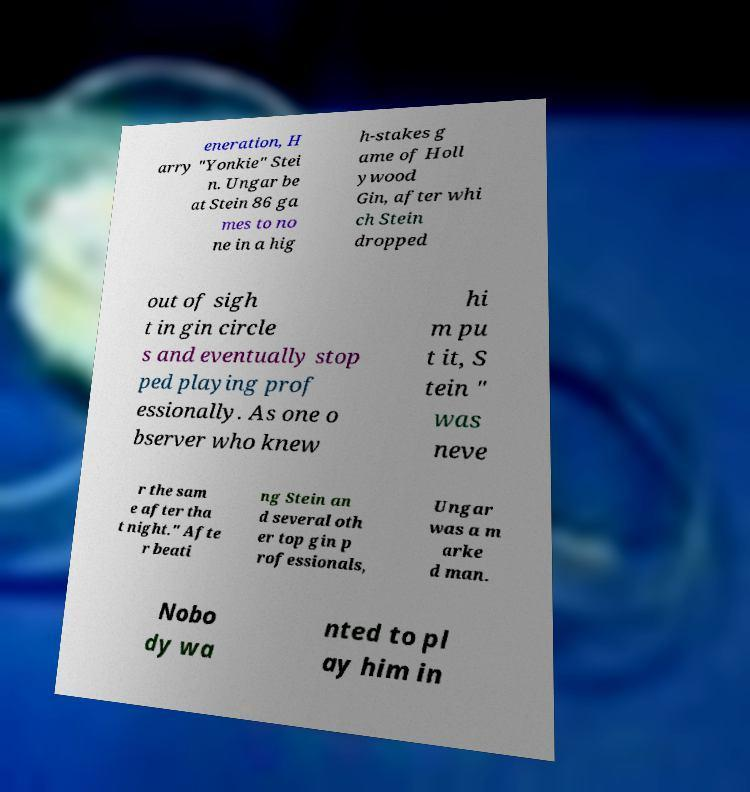Please identify and transcribe the text found in this image. eneration, H arry "Yonkie" Stei n. Ungar be at Stein 86 ga mes to no ne in a hig h-stakes g ame of Holl ywood Gin, after whi ch Stein dropped out of sigh t in gin circle s and eventually stop ped playing prof essionally. As one o bserver who knew hi m pu t it, S tein " was neve r the sam e after tha t night." Afte r beati ng Stein an d several oth er top gin p rofessionals, Ungar was a m arke d man. Nobo dy wa nted to pl ay him in 